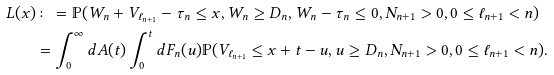<formula> <loc_0><loc_0><loc_500><loc_500>L ( x ) & \colon = \mathbb { P } ( W _ { n } + V _ { \ell _ { n + 1 } } - \tau _ { n } \leq x , W _ { n } \geq D _ { n } , W _ { n } - \tau _ { n } \leq 0 , N _ { n + 1 } > 0 , 0 \leq \ell _ { n + 1 } < n ) \\ & = \int _ { 0 } ^ { \infty } d A ( t ) \int _ { 0 } ^ { t } d F _ { n } ( u ) \mathbb { P } ( V _ { \ell _ { n + 1 } } \leq x + t - u , u \geq D _ { n } , N _ { n + 1 } > 0 , 0 \leq \ell _ { n + 1 } < n ) .</formula> 